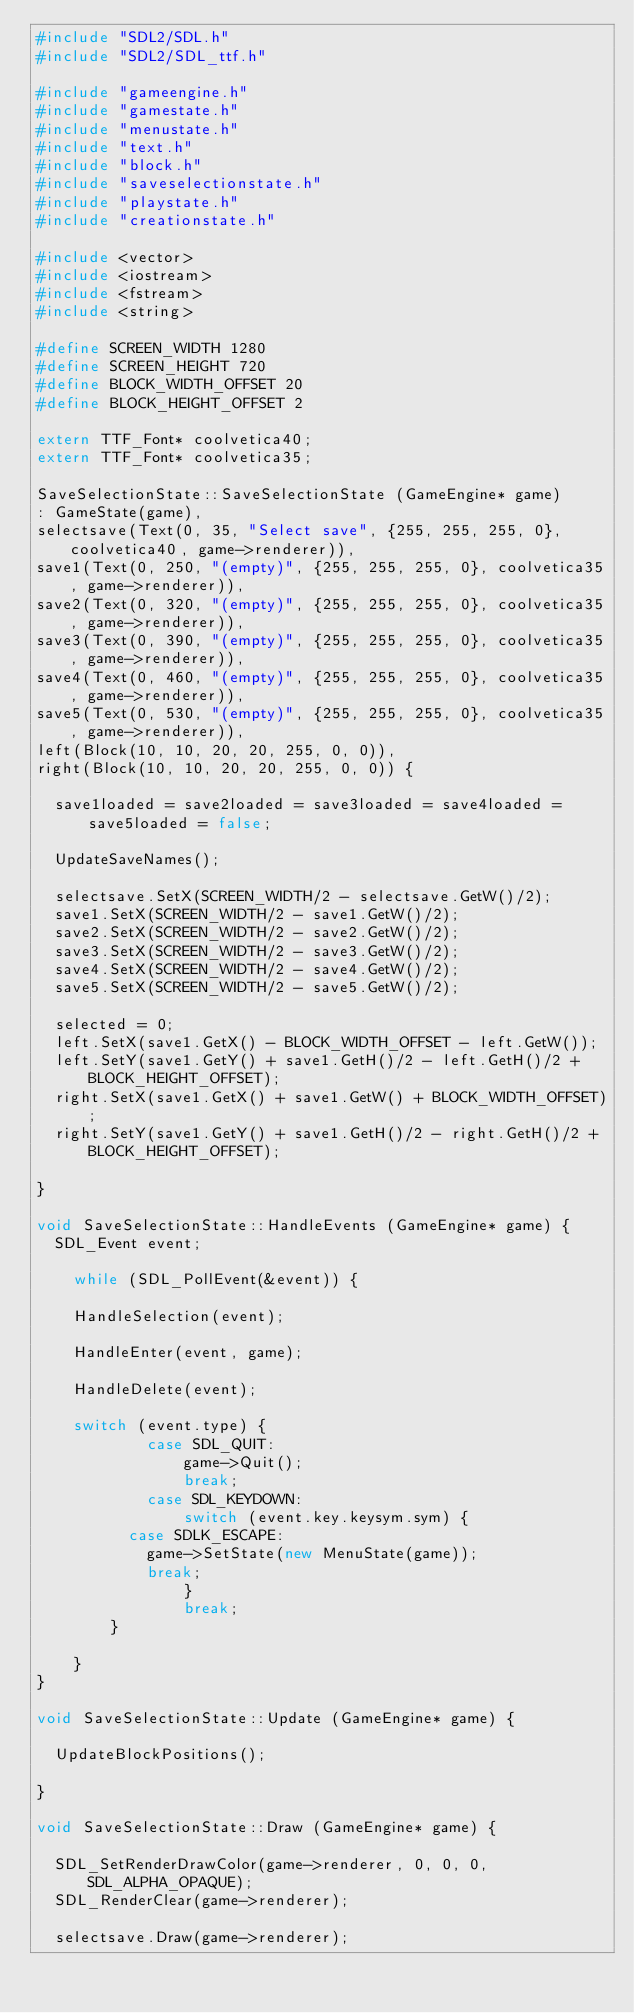Convert code to text. <code><loc_0><loc_0><loc_500><loc_500><_C++_>#include "SDL2/SDL.h"
#include "SDL2/SDL_ttf.h"

#include "gameengine.h"
#include "gamestate.h"
#include "menustate.h"
#include "text.h"
#include "block.h"
#include "saveselectionstate.h"
#include "playstate.h"
#include "creationstate.h"

#include <vector>
#include <iostream>
#include <fstream>
#include <string>

#define SCREEN_WIDTH 1280
#define SCREEN_HEIGHT 720
#define BLOCK_WIDTH_OFFSET 20
#define BLOCK_HEIGHT_OFFSET 2

extern TTF_Font* coolvetica40;
extern TTF_Font* coolvetica35;

SaveSelectionState::SaveSelectionState (GameEngine* game)
: GameState(game),
selectsave(Text(0, 35, "Select save", {255, 255, 255, 0}, coolvetica40, game->renderer)),
save1(Text(0, 250, "(empty)", {255, 255, 255, 0}, coolvetica35, game->renderer)),
save2(Text(0, 320, "(empty)", {255, 255, 255, 0}, coolvetica35, game->renderer)),
save3(Text(0, 390, "(empty)", {255, 255, 255, 0}, coolvetica35, game->renderer)),
save4(Text(0, 460, "(empty)", {255, 255, 255, 0}, coolvetica35, game->renderer)),
save5(Text(0, 530, "(empty)", {255, 255, 255, 0}, coolvetica35, game->renderer)),
left(Block(10, 10, 20, 20, 255, 0, 0)),
right(Block(10, 10, 20, 20, 255, 0, 0)) {

  save1loaded = save2loaded = save3loaded = save4loaded = save5loaded = false;

  UpdateSaveNames();

  selectsave.SetX(SCREEN_WIDTH/2 - selectsave.GetW()/2);
  save1.SetX(SCREEN_WIDTH/2 - save1.GetW()/2);
  save2.SetX(SCREEN_WIDTH/2 - save2.GetW()/2);
  save3.SetX(SCREEN_WIDTH/2 - save3.GetW()/2);
  save4.SetX(SCREEN_WIDTH/2 - save4.GetW()/2);
  save5.SetX(SCREEN_WIDTH/2 - save5.GetW()/2);

  selected = 0;
  left.SetX(save1.GetX() - BLOCK_WIDTH_OFFSET - left.GetW());
  left.SetY(save1.GetY() + save1.GetH()/2 - left.GetH()/2 + BLOCK_HEIGHT_OFFSET);
  right.SetX(save1.GetX() + save1.GetW() + BLOCK_WIDTH_OFFSET);
  right.SetY(save1.GetY() + save1.GetH()/2 - right.GetH()/2 + BLOCK_HEIGHT_OFFSET);

}

void SaveSelectionState::HandleEvents (GameEngine* game) {
  SDL_Event event;

	while (SDL_PollEvent(&event)) {

    HandleSelection(event);

    HandleEnter(event, game);

    HandleDelete(event);

    switch (event.type) {
			case SDL_QUIT:
				game->Quit();
				break;
			case SDL_KEYDOWN:
				switch (event.key.keysym.sym) {
          case SDLK_ESCAPE:
            game->SetState(new MenuState(game));
            break;
				}
				break;
		}

	}
}

void SaveSelectionState::Update (GameEngine* game) {

  UpdateBlockPositions();

}

void SaveSelectionState::Draw (GameEngine* game) {

  SDL_SetRenderDrawColor(game->renderer, 0, 0, 0, SDL_ALPHA_OPAQUE);
  SDL_RenderClear(game->renderer);

  selectsave.Draw(game->renderer);</code> 